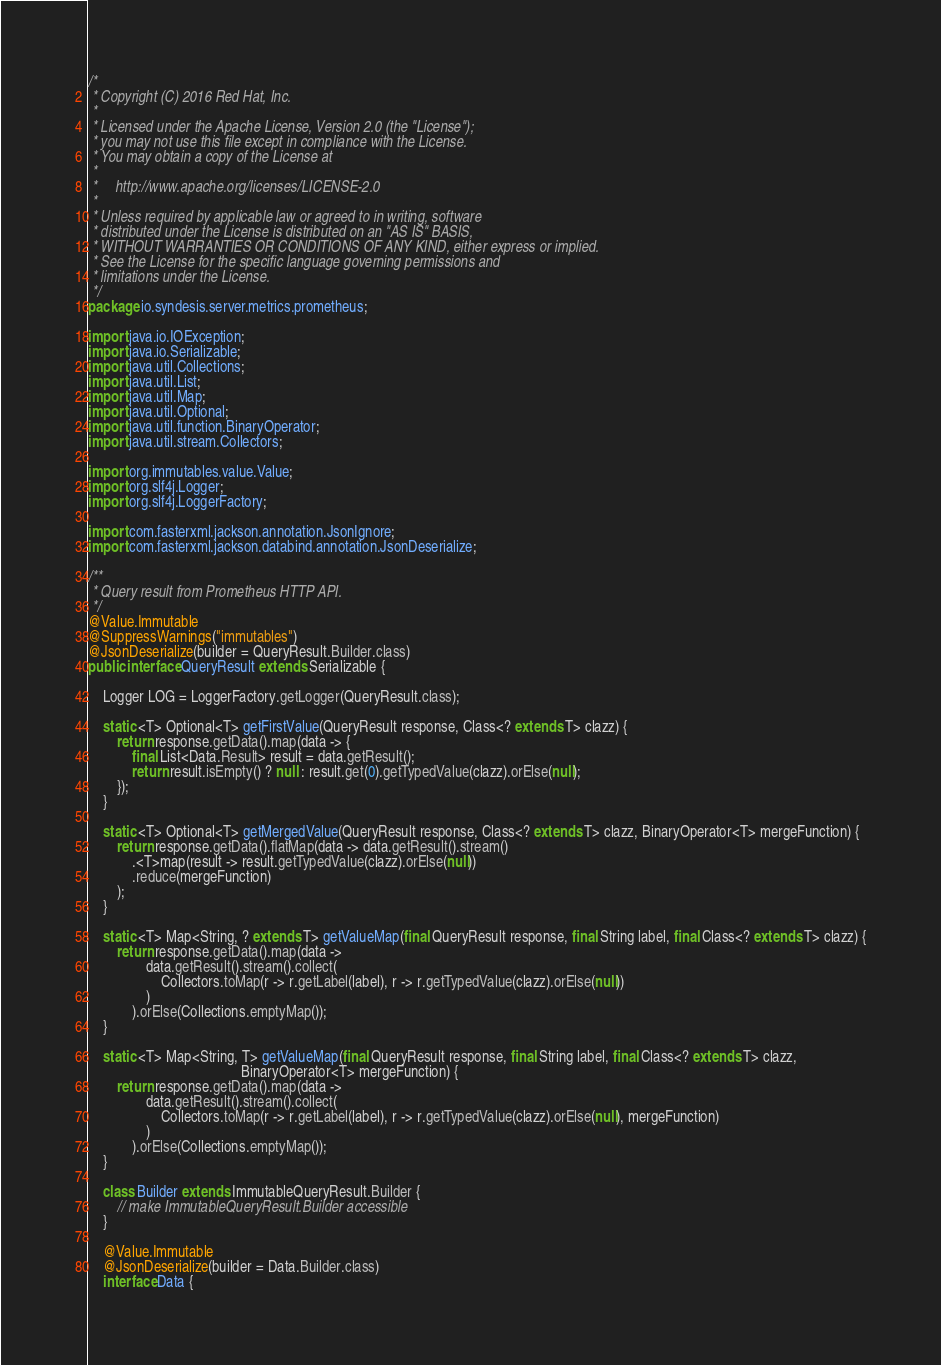Convert code to text. <code><loc_0><loc_0><loc_500><loc_500><_Java_>/*
 * Copyright (C) 2016 Red Hat, Inc.
 *
 * Licensed under the Apache License, Version 2.0 (the "License");
 * you may not use this file except in compliance with the License.
 * You may obtain a copy of the License at
 *
 *     http://www.apache.org/licenses/LICENSE-2.0
 *
 * Unless required by applicable law or agreed to in writing, software
 * distributed under the License is distributed on an "AS IS" BASIS,
 * WITHOUT WARRANTIES OR CONDITIONS OF ANY KIND, either express or implied.
 * See the License for the specific language governing permissions and
 * limitations under the License.
 */
package io.syndesis.server.metrics.prometheus;

import java.io.IOException;
import java.io.Serializable;
import java.util.Collections;
import java.util.List;
import java.util.Map;
import java.util.Optional;
import java.util.function.BinaryOperator;
import java.util.stream.Collectors;

import org.immutables.value.Value;
import org.slf4j.Logger;
import org.slf4j.LoggerFactory;

import com.fasterxml.jackson.annotation.JsonIgnore;
import com.fasterxml.jackson.databind.annotation.JsonDeserialize;

/**
 * Query result from Prometheus HTTP API.
 */
@Value.Immutable
@SuppressWarnings("immutables")
@JsonDeserialize(builder = QueryResult.Builder.class)
public interface QueryResult extends Serializable {

    Logger LOG = LoggerFactory.getLogger(QueryResult.class);

    static <T> Optional<T> getFirstValue(QueryResult response, Class<? extends T> clazz) {
        return response.getData().map(data -> {
            final List<Data.Result> result = data.getResult();
            return result.isEmpty() ? null : result.get(0).getTypedValue(clazz).orElse(null);
        });
    }

    static <T> Optional<T> getMergedValue(QueryResult response, Class<? extends T> clazz, BinaryOperator<T> mergeFunction) {
        return response.getData().flatMap(data -> data.getResult().stream()
            .<T>map(result -> result.getTypedValue(clazz).orElse(null))
            .reduce(mergeFunction)
        );
    }

    static <T> Map<String, ? extends T> getValueMap(final QueryResult response, final String label, final Class<? extends T> clazz) {
        return response.getData().map(data ->
                data.getResult().stream().collect(
                    Collectors.toMap(r -> r.getLabel(label), r -> r.getTypedValue(clazz).orElse(null))
                )
            ).orElse(Collections.emptyMap());
    }

    static <T> Map<String, T> getValueMap(final QueryResult response, final String label, final Class<? extends T> clazz,
                                          BinaryOperator<T> mergeFunction) {
        return response.getData().map(data ->
                data.getResult().stream().collect(
                    Collectors.toMap(r -> r.getLabel(label), r -> r.getTypedValue(clazz).orElse(null), mergeFunction)
                )
            ).orElse(Collections.emptyMap());
    }

    class Builder extends ImmutableQueryResult.Builder {
        // make ImmutableQueryResult.Builder accessible
    }

    @Value.Immutable
    @JsonDeserialize(builder = Data.Builder.class)
    interface Data {
</code> 